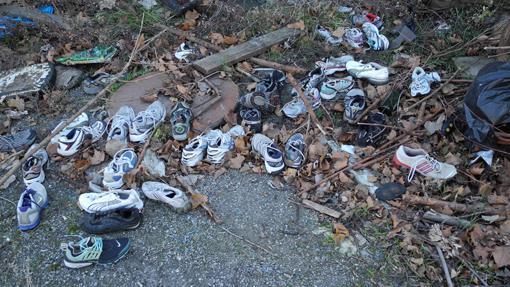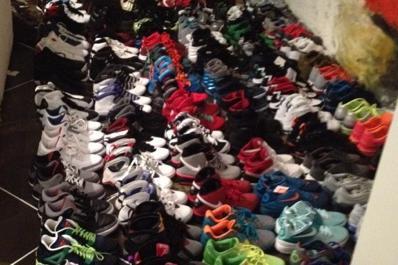The first image is the image on the left, the second image is the image on the right. Considering the images on both sides, is "There is a pair of athletic shoes sitting outside in the grass." valid? Answer yes or no. No. The first image is the image on the left, the second image is the image on the right. Considering the images on both sides, is "there are at most2 pair of shoes per image pair" valid? Answer yes or no. No. 